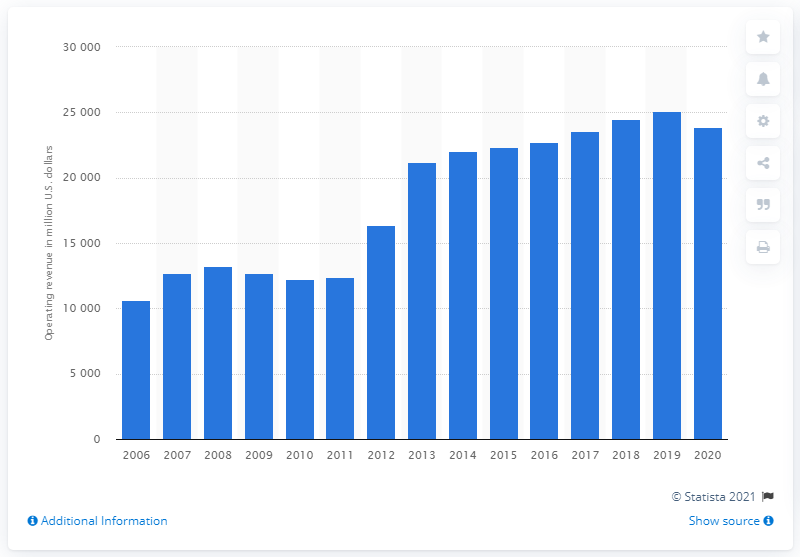Indicate a few pertinent items in this graphic. Duke Energy's operating revenue increased significantly between 2006 and 2020, with a growth of 13,207%. In the fiscal year 2020, Duke Energy reported operating revenue of $238,688. 